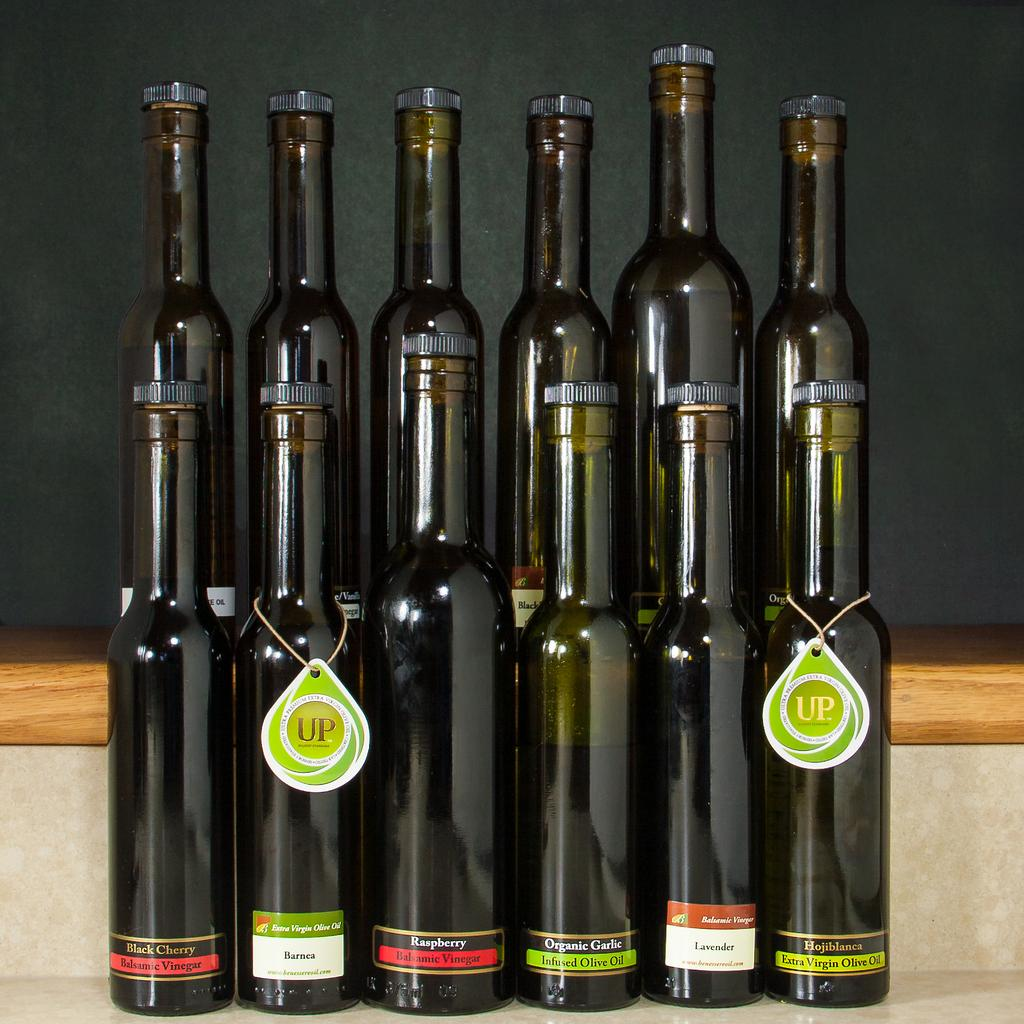<image>
Create a compact narrative representing the image presented. 12 sleek bottles of various balsamic vinegars and soe olive oil varieties 